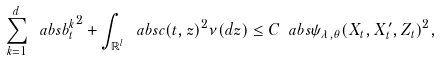Convert formula to latex. <formula><loc_0><loc_0><loc_500><loc_500>\sum _ { k = 1 } ^ { d } \ a b s { b ^ { k } _ { t } } ^ { 2 } + \int _ { \mathbb { R } ^ { l } } \ a b s { c ( t , z ) } ^ { 2 } \nu ( d z ) \leq C \ a b s { \psi _ { \lambda , \theta } ( X _ { t } , X ^ { \prime } _ { t } , Z _ { t } ) } ^ { 2 } ,</formula> 